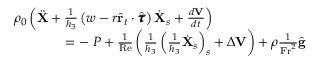<formula> <loc_0><loc_0><loc_500><loc_500>\begin{array} { r } { \rho _ { 0 } \left ( \ddot { X } + \frac { 1 } { h _ { 3 } } \left ( w - r \hat { r } _ { t } \cdot \hat { \pm b { \tau } } \right ) \dot { X } _ { s } + \frac { d V } { d t } \right ) \quad } \\ { = - \nabla P + \frac { 1 } { R e } \left ( \frac { 1 } { h _ { 3 } } \left ( \frac { 1 } { h _ { 3 } } \dot { X } _ { s } \right ) _ { s } + \Delta V \right ) + \rho \frac { 1 } { F r ^ { 2 } } \hat { g } } \end{array}</formula> 